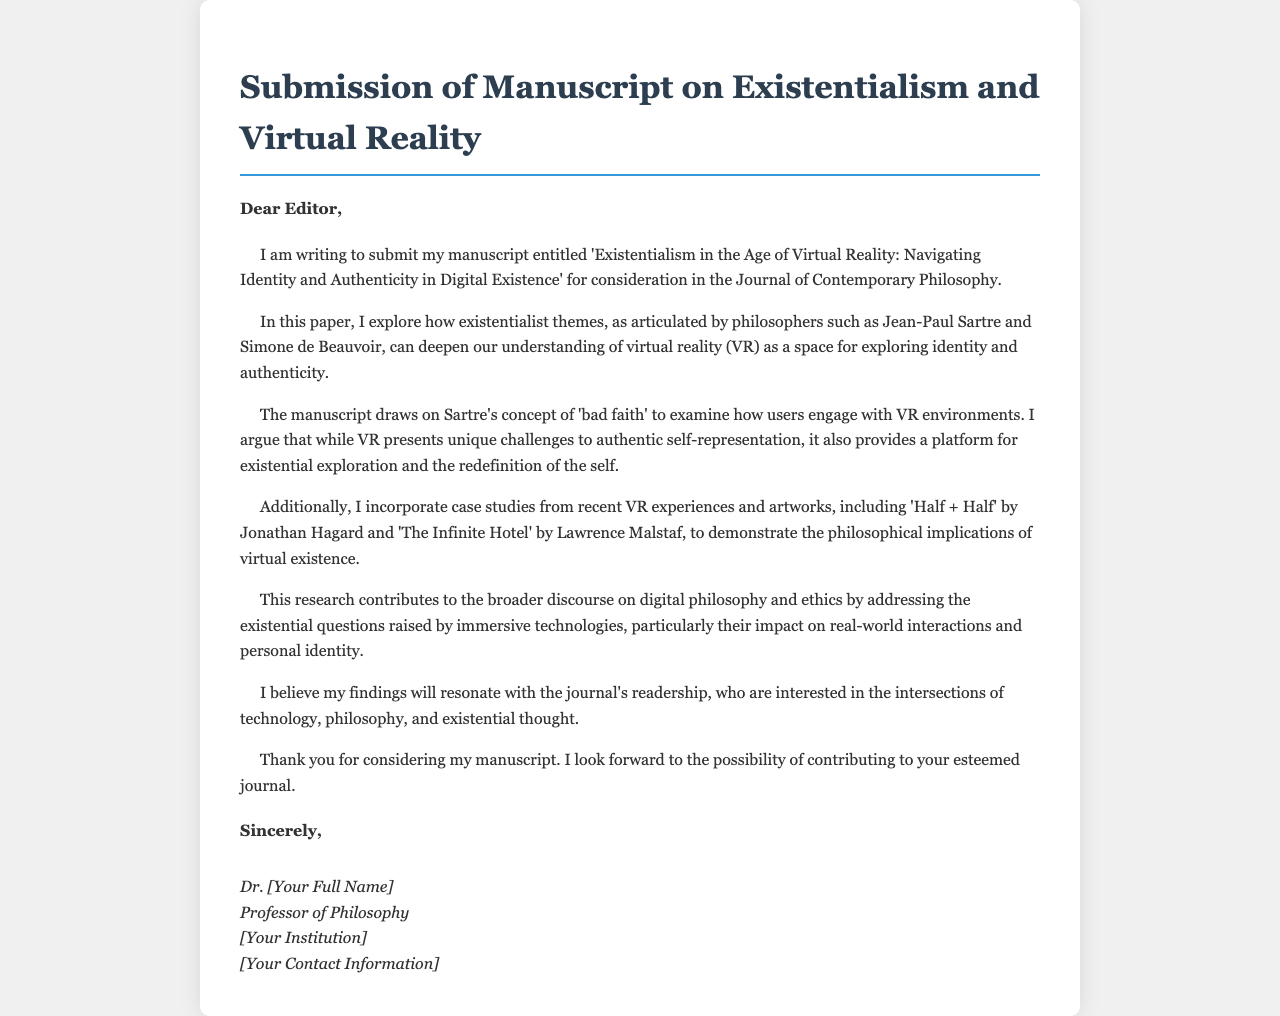What is the title of the manuscript? The title is stated at the beginning of the submission and reflects the main focus of the research.
Answer: Existentialism in the Age of Virtual Reality: Navigating Identity and Authenticity in Digital Existence Who is the author of the manuscript? The author’s name is typically mentioned in the signature section at the end of the letter.
Answer: Dr. [Your Full Name] Which journal is the manuscript submitted to? The journal is specified in the opening paragraph of the letter.
Answer: Journal of Contemporary Philosophy What philosophical concept does the manuscript draw on? The manuscript mentions this specific concept while discussing user engagement with VR environments.
Answer: Bad faith Name one VR experience used in the case studies. The letter includes examples of VR experiences that illustrate the philosophical implications discussed.
Answer: Half + Half What themes from existentialist philosophers does the paper explore? The themes are outlined in relation to virtual reality and the exploration of identity and authenticity.
Answer: Identity and authenticity What is the main argument of the paper regarding VR? The argument is presented in the context of how VR affects authentic self-representation and existential exploration.
Answer: Unique challenges for authentic self-representation What does the author hope to contribute to the journal? The author’s intention is clearly stated in the closing sentences of the letter.
Answer: Contributing to digital philosophy and ethics What is mentioned as a challenge within VR? A specific challenge is highlighted in relation to participants' representation in virtual environments.
Answer: Authentic self-representation 